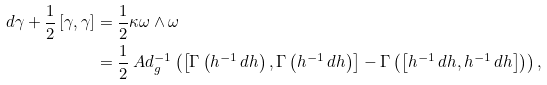<formula> <loc_0><loc_0><loc_500><loc_500>d \gamma + \frac { 1 } { 2 } \left [ \gamma , \gamma \right ] & = \frac { 1 } { 2 } \kappa \omega \wedge \omega \\ & = \frac { 1 } { 2 } \ A d _ { g } ^ { - 1 } \left ( \left [ \Gamma \left ( h ^ { - 1 } \, d h \right ) , \Gamma \left ( h ^ { - 1 } \, d h \right ) \right ] - \Gamma \left ( \left [ h ^ { - 1 } \, d h , h ^ { - 1 } \, d h \right ] \right ) \right ) ,</formula> 